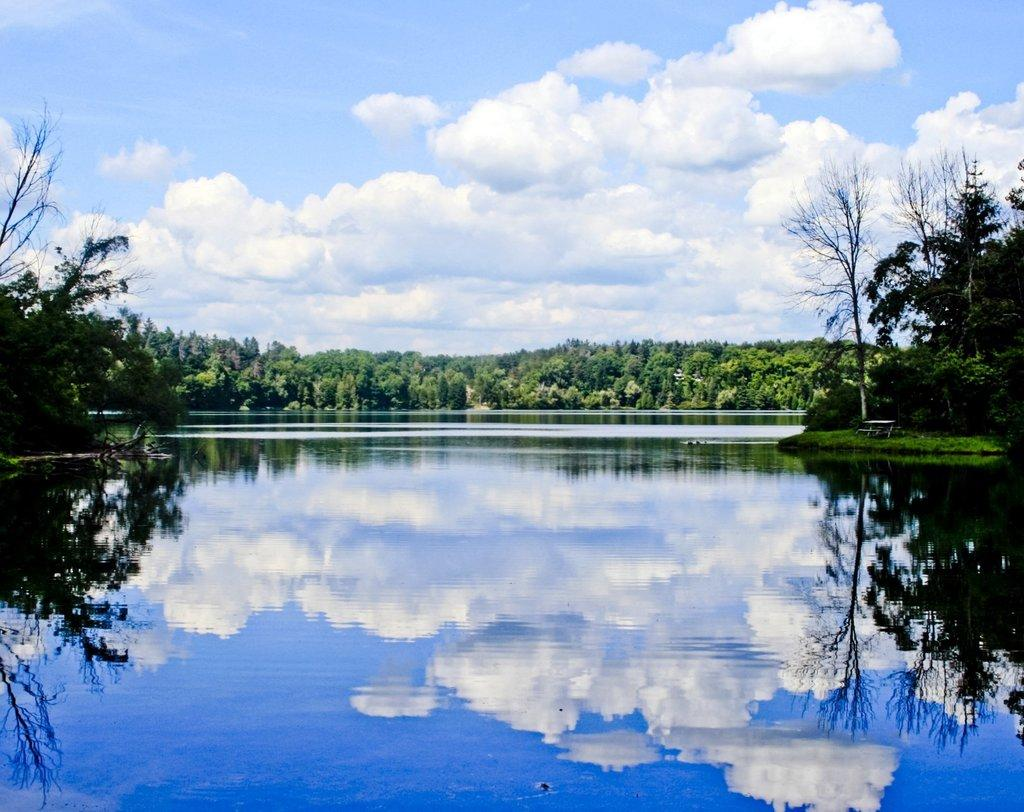What body of water is visible in the image? There is a lake in the image. What can be seen reflected on the surface of the lake? The lake has clouds reflected on its surface. What type of vegetation is visible in the background of the image? There are trees in the background of the image. What is visible above the lake in the image? The sky is visible in the image. What can be seen in the sky in the image? Clouds are present in the sky. How does the lake express regret in the image? The lake does not express regret in the image, as it is a natural body of water and does not have emotions or the ability to express them. 